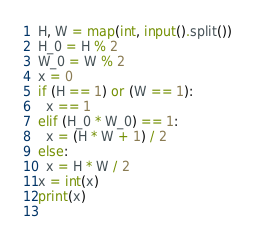Convert code to text. <code><loc_0><loc_0><loc_500><loc_500><_Python_>H, W = map(int, input().split())
H_0 = H % 2
W_0 = W % 2
x = 0
if (H == 1) or (W == 1):
  x == 1
elif (H_0 * W_0) == 1:
  x = (H * W + 1) / 2
else:
  x = H * W / 2
x = int(x)
print(x)
 </code> 